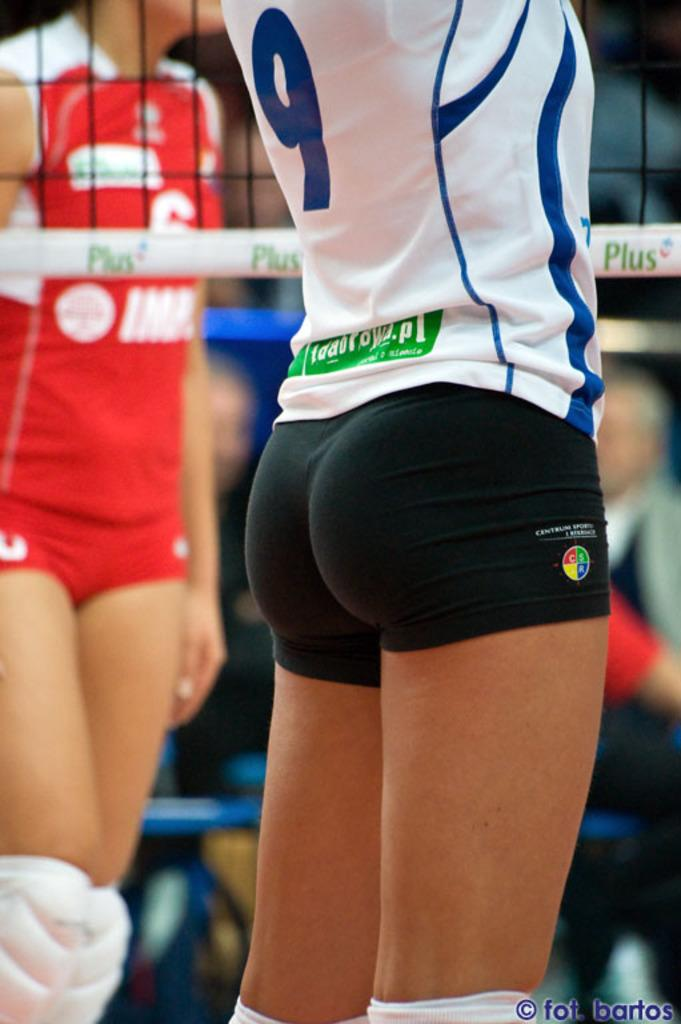<image>
Relay a brief, clear account of the picture shown. The number 9 lady volleyball player is shown from the back. 